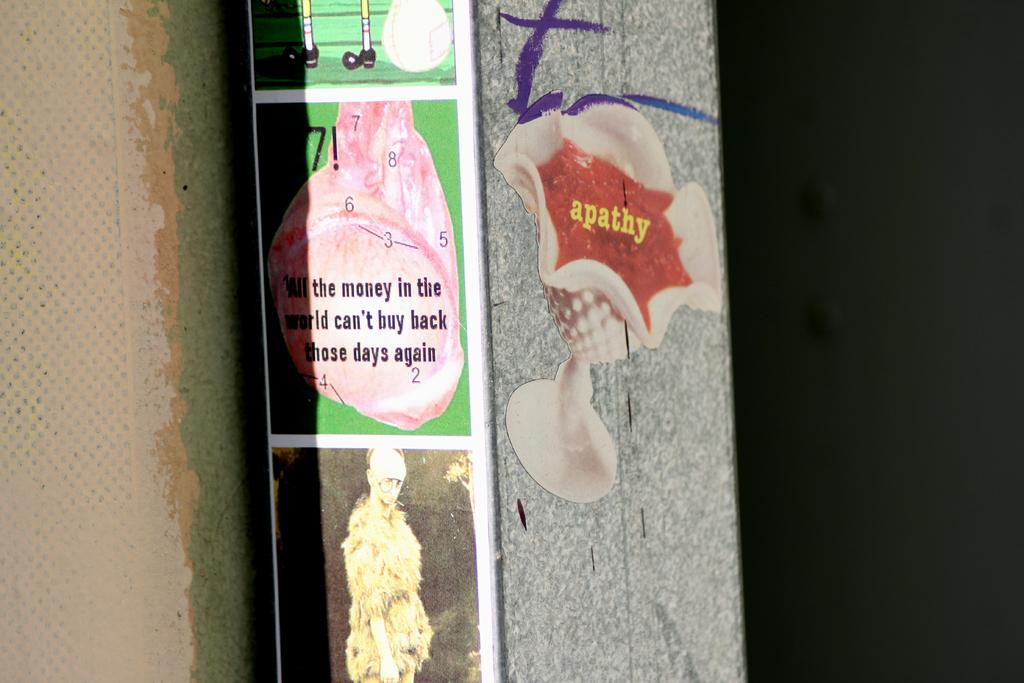What can be seen on the wall in the image? There are posts on the wall in the image. What type of fiction is the partner reading in the image? There is no partner or fiction present in the image; it only shows posts on the wall. 